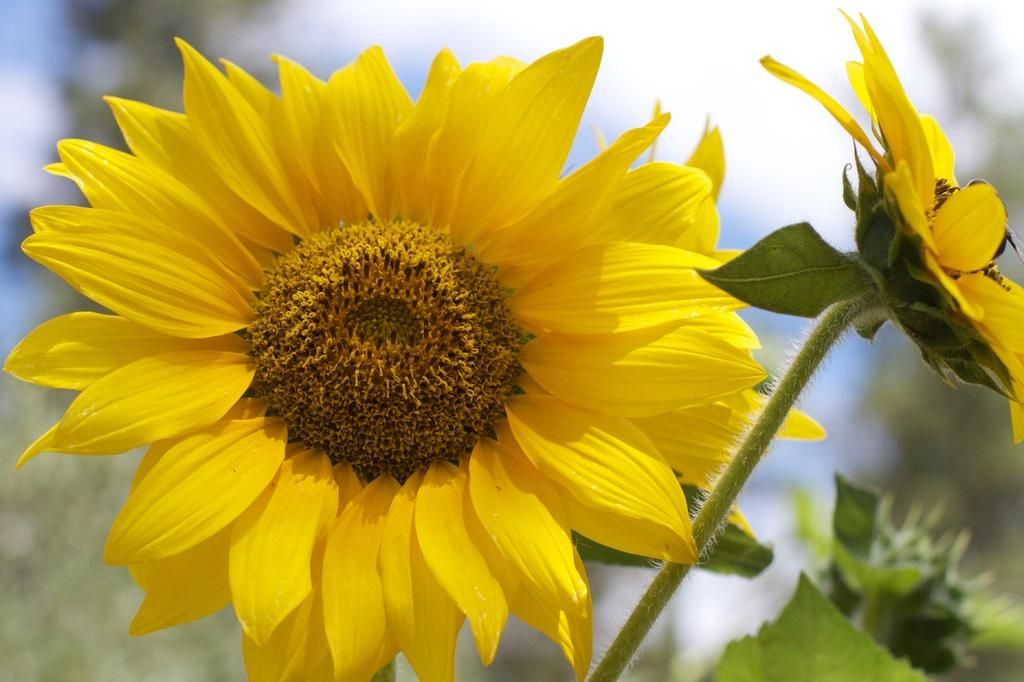What type of living organisms are present in the image? There are flowers in the image. What part of the flowers connects them to the plant? The flowers have stems. What part of the plant is visible in the image? There are leaves on the plant in the image. Where is the vase located in the image? There is no vase present in the image. What type of shelf is holding the flowers in the image? There is no shelf present in the image. 